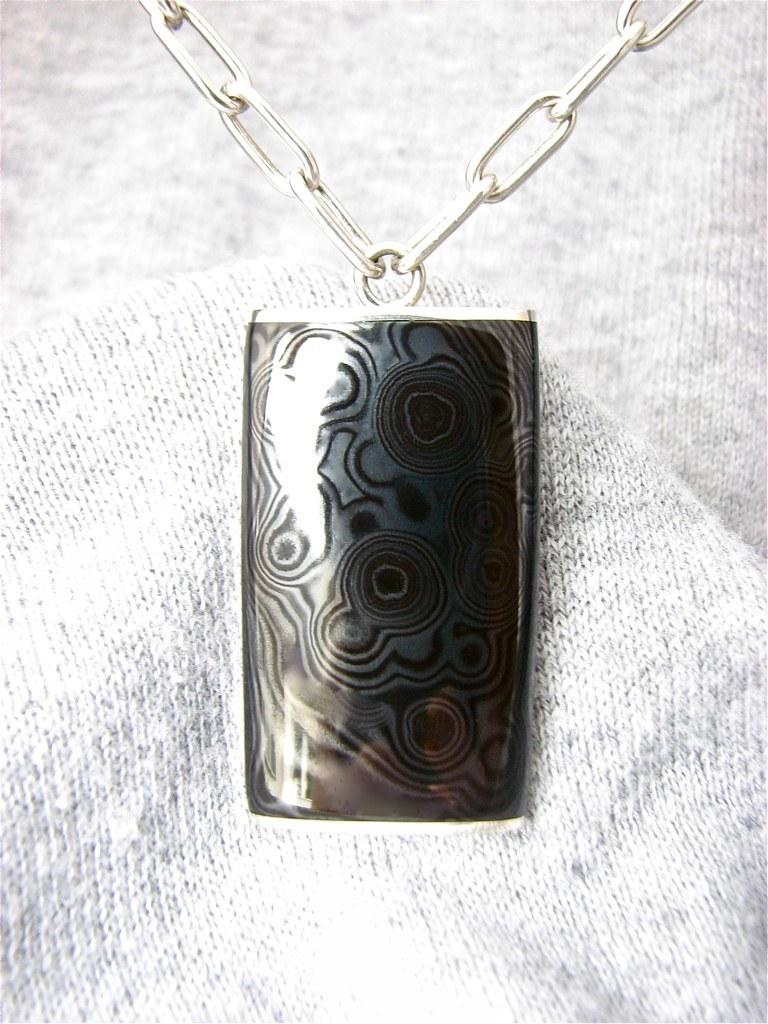What is present in the image that connects two objects together? There is a chain in the image that connects two objects together. What is one of the objects connected by the chain? There is a locket in the image that is connected by the chain. On what surface are the chain and locket placed? The chain and locket are on a white and ash color cloth. How many buildings can be seen in the image? There are no buildings present in the image; it features a chain and locket on a cloth. What type of finger is shown interacting with the chain and locket in the image? There are no fingers present in the image; it only features a chain and locket on a cloth. 